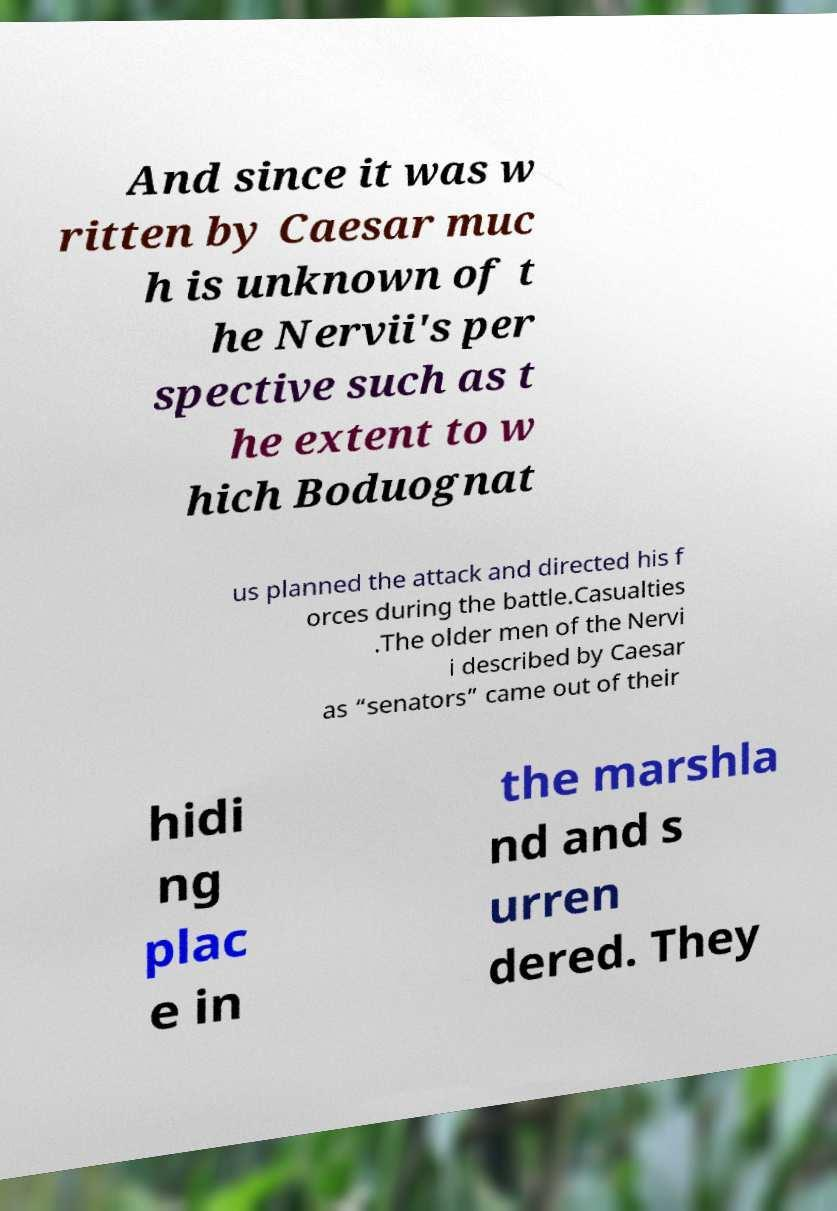Can you read and provide the text displayed in the image?This photo seems to have some interesting text. Can you extract and type it out for me? And since it was w ritten by Caesar muc h is unknown of t he Nervii's per spective such as t he extent to w hich Boduognat us planned the attack and directed his f orces during the battle.Casualties .The older men of the Nervi i described by Caesar as “senators” came out of their hidi ng plac e in the marshla nd and s urren dered. They 